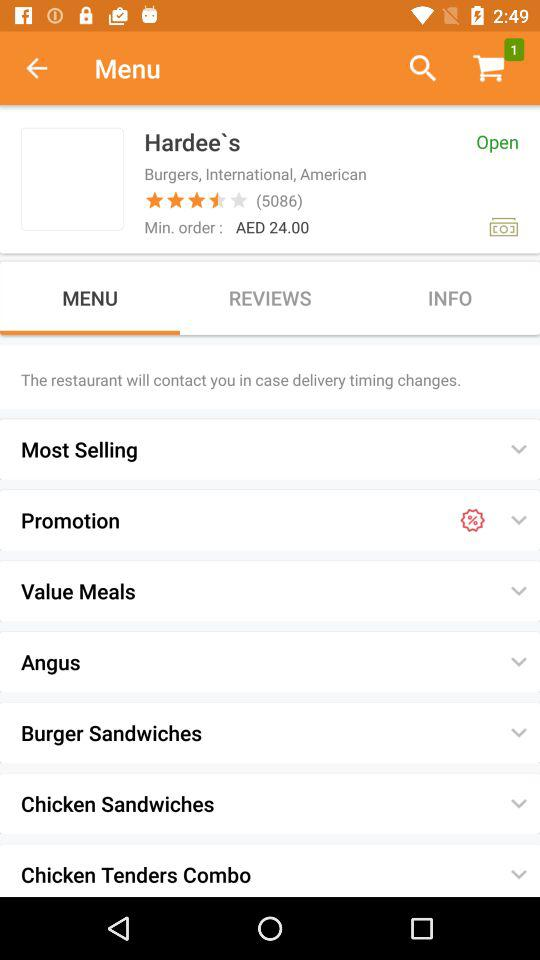Which tab is selected? The selected tab is "MENU". 